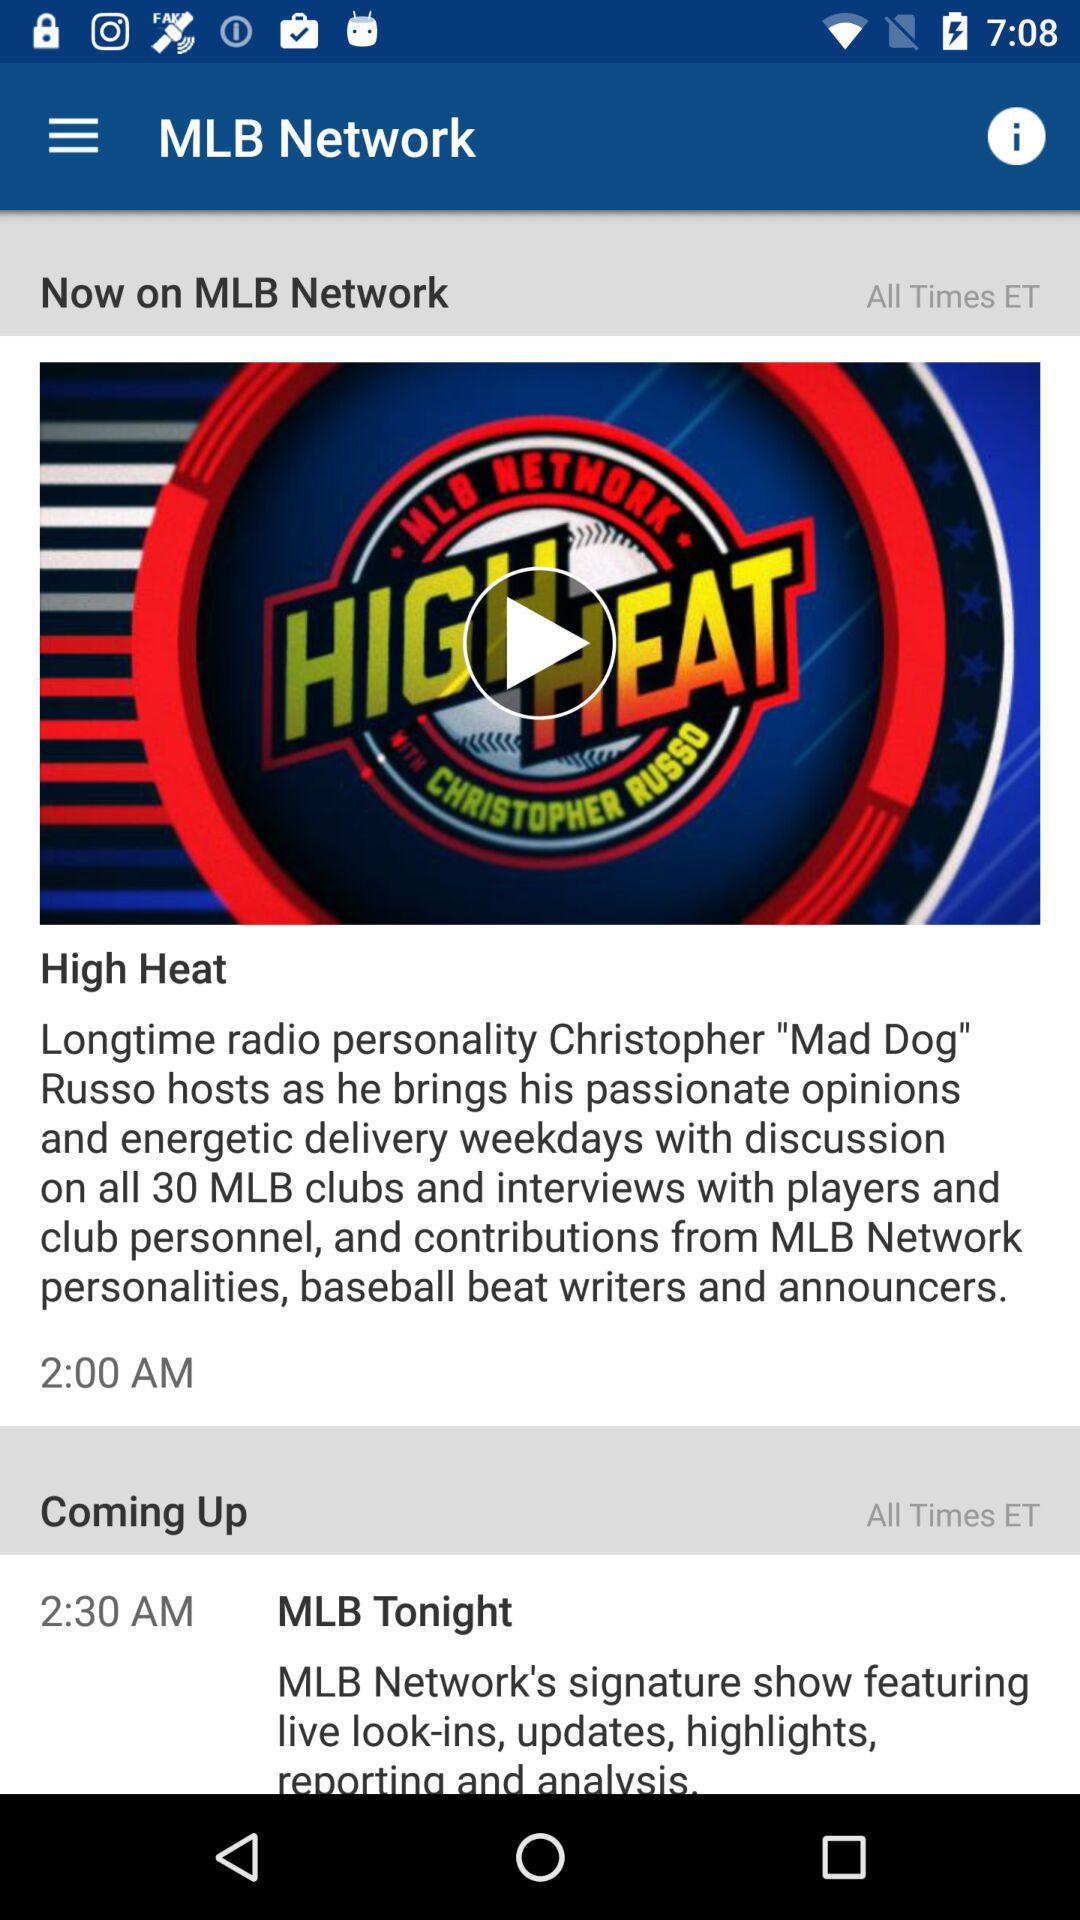What is the application name? The application name is "MLB Network". 